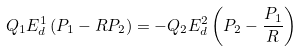<formula> <loc_0><loc_0><loc_500><loc_500>Q _ { 1 } E ^ { 1 } _ { d } \left ( P _ { 1 } - R P _ { 2 } \right ) = - Q _ { 2 } E ^ { 2 } _ { d } \left ( P _ { 2 } - \frac { P _ { 1 } } { R } \right )</formula> 